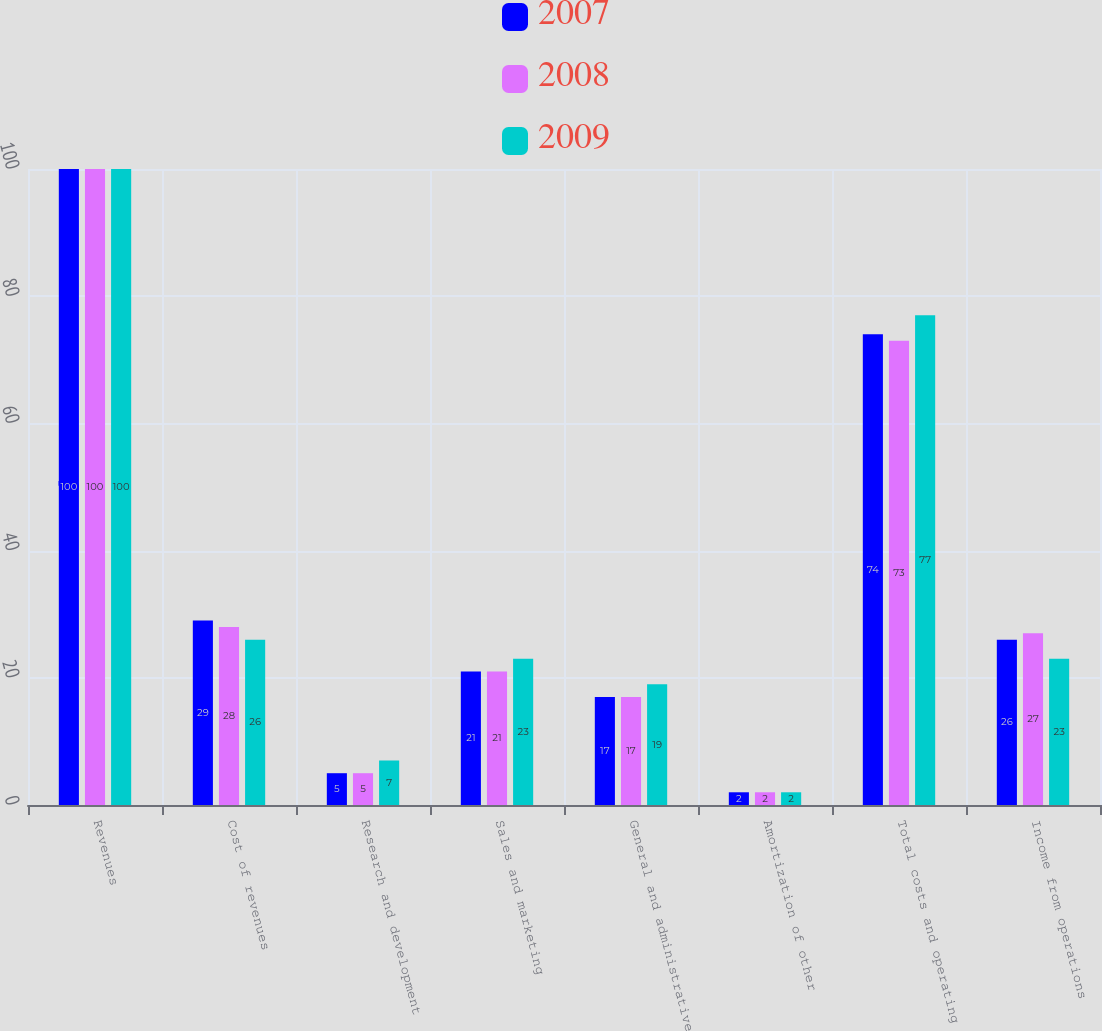<chart> <loc_0><loc_0><loc_500><loc_500><stacked_bar_chart><ecel><fcel>Revenues<fcel>Cost of revenues<fcel>Research and development<fcel>Sales and marketing<fcel>General and administrative<fcel>Amortization of other<fcel>Total costs and operating<fcel>Income from operations<nl><fcel>2007<fcel>100<fcel>29<fcel>5<fcel>21<fcel>17<fcel>2<fcel>74<fcel>26<nl><fcel>2008<fcel>100<fcel>28<fcel>5<fcel>21<fcel>17<fcel>2<fcel>73<fcel>27<nl><fcel>2009<fcel>100<fcel>26<fcel>7<fcel>23<fcel>19<fcel>2<fcel>77<fcel>23<nl></chart> 